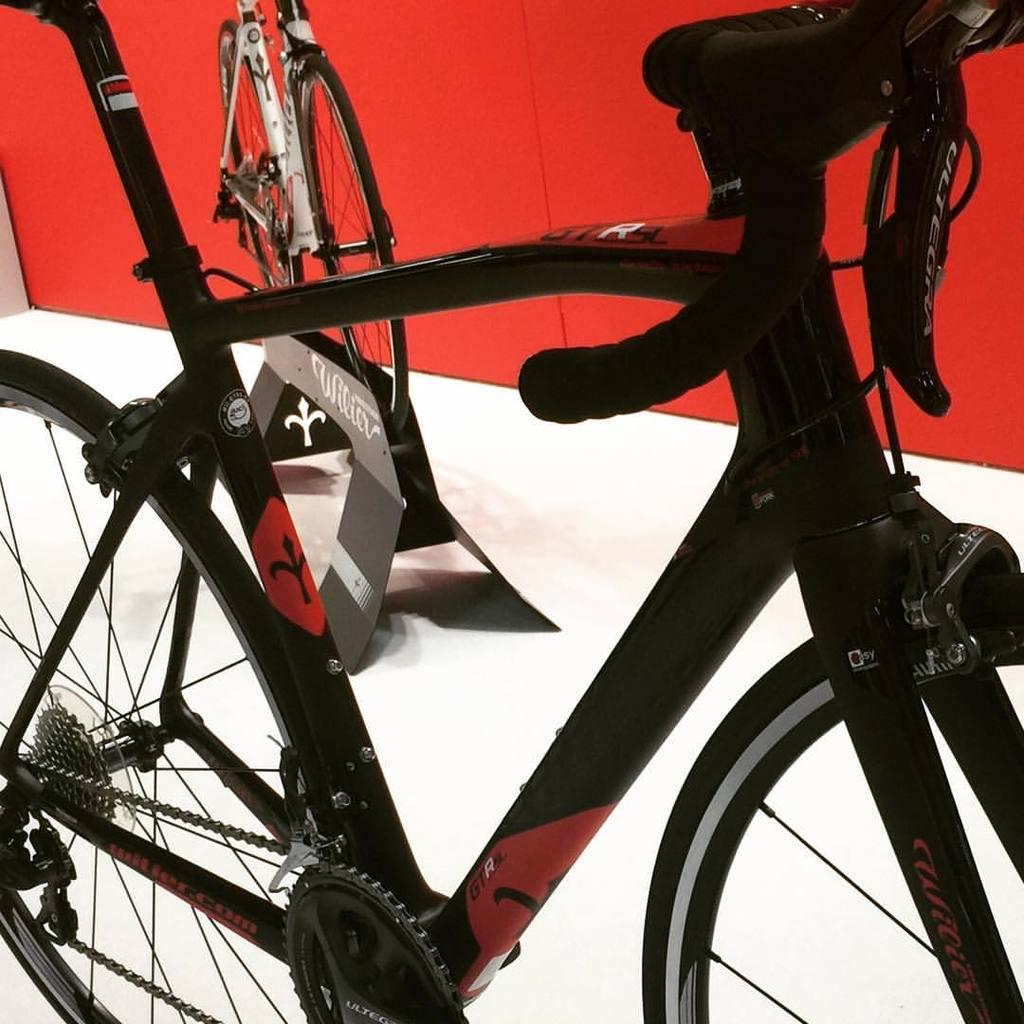How many bicycles are in the image? There are two bicycles in the image. What colors are the bicycles? The bicycles are in black and white colors. What can be seen in the background of the image? There is a wall in the background of the image. What color is the wall? The wall is in red color. What month is it in the image? The image does not provide any information about the month or time of year. Can you hear the voice of the person who took the image? The image is a still photograph and does not contain any audio, so we cannot hear any voices. 